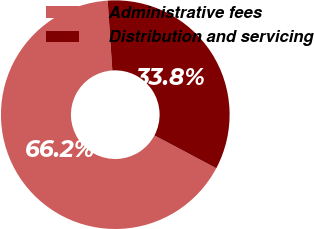Convert chart. <chart><loc_0><loc_0><loc_500><loc_500><pie_chart><fcel>Administrative fees<fcel>Distribution and servicing<nl><fcel>66.18%<fcel>33.82%<nl></chart> 